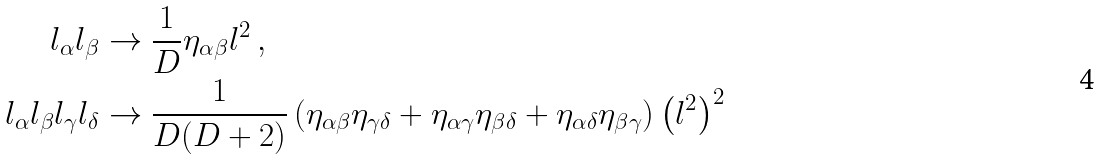<formula> <loc_0><loc_0><loc_500><loc_500>l _ { \alpha } l _ { \beta } & \to \frac { 1 } { D } \eta _ { \alpha \beta } l ^ { 2 } \, , \\ l _ { \alpha } l _ { \beta } l _ { \gamma } l _ { \delta } & \to \frac { 1 } { D ( D + 2 ) } \left ( \eta _ { \alpha \beta } \eta _ { \gamma \delta } + \eta _ { \alpha \gamma } \eta _ { \beta \delta } + \eta _ { \alpha \delta } \eta _ { \beta \gamma } \right ) \left ( l ^ { 2 } \right ) ^ { 2 } \,</formula> 